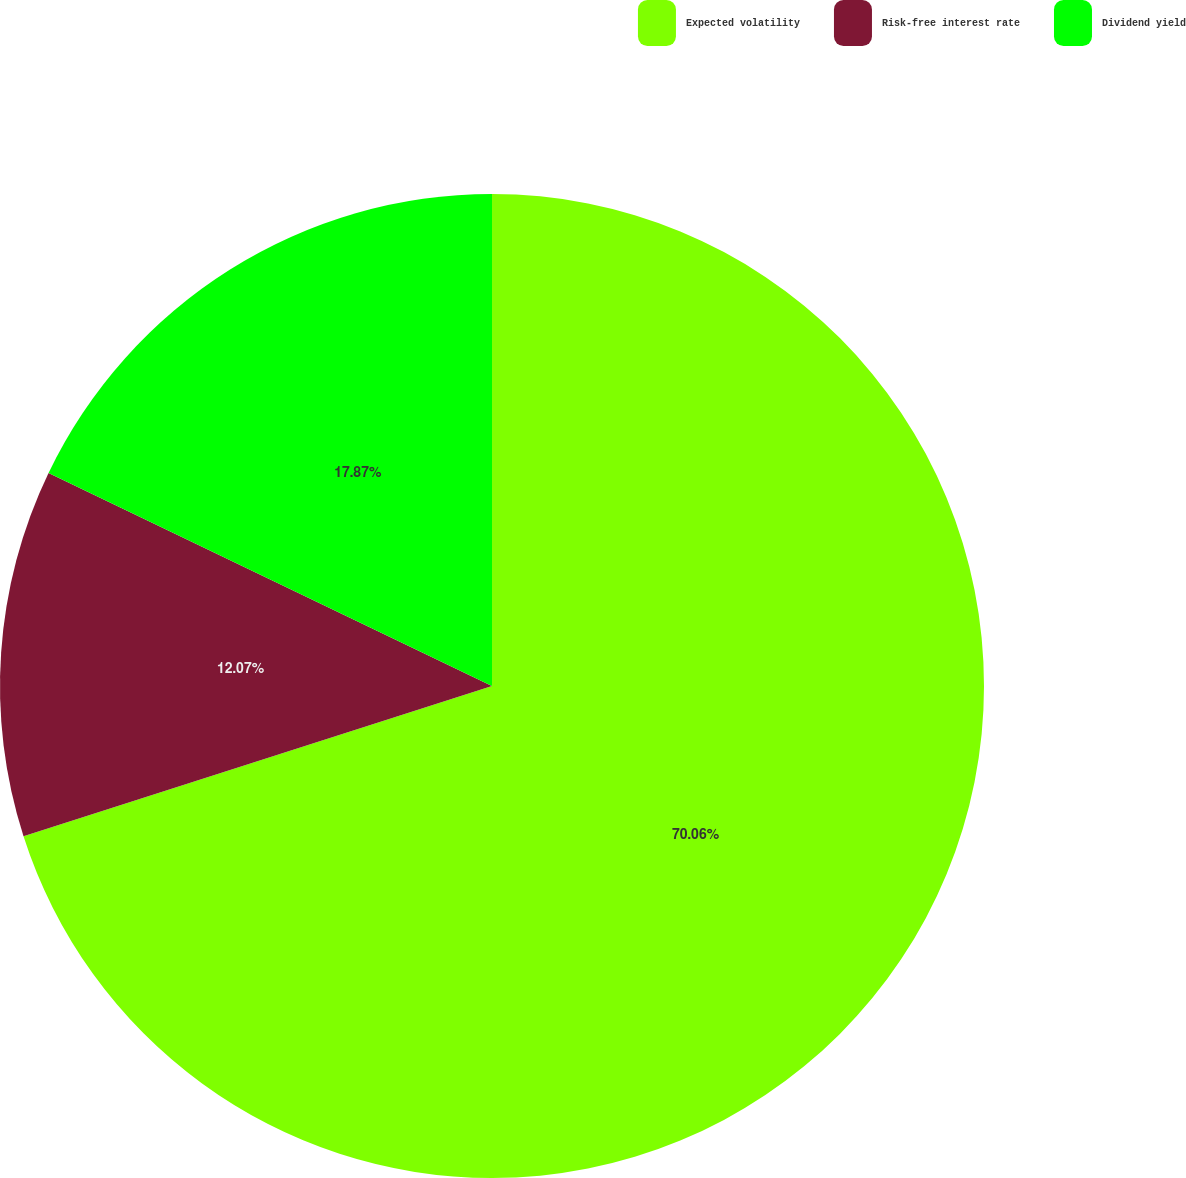<chart> <loc_0><loc_0><loc_500><loc_500><pie_chart><fcel>Expected volatility<fcel>Risk-free interest rate<fcel>Dividend yield<nl><fcel>70.06%<fcel>12.07%<fcel>17.87%<nl></chart> 